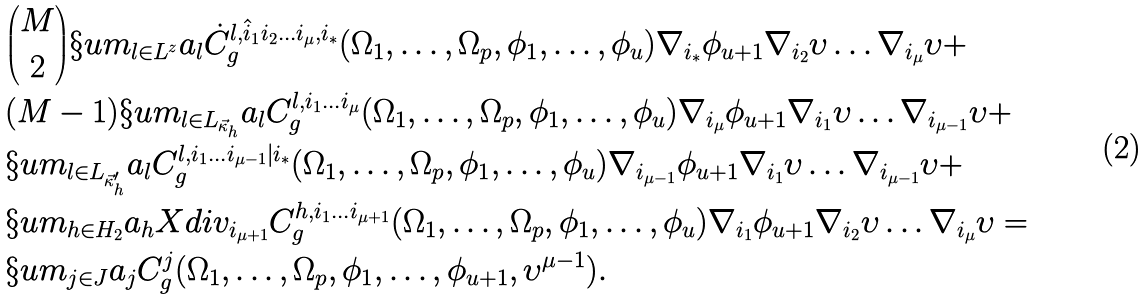Convert formula to latex. <formula><loc_0><loc_0><loc_500><loc_500>& { { M } \choose { 2 } } \S u m _ { l \in L ^ { z } } a _ { l } \dot { C } ^ { l , \hat { i } _ { 1 } i _ { 2 } \dots i _ { \mu } , i _ { * } } _ { g } ( \Omega _ { 1 } , \dots , \Omega _ { p } , \phi _ { 1 } , \dots , \phi _ { u } ) \nabla _ { i _ { * } } \phi _ { u + 1 } \nabla _ { i _ { 2 } } \upsilon \dots \nabla _ { i _ { \mu } } \upsilon + \\ & ( M - 1 ) \S u m _ { l \in L _ { \vec { \kappa } _ { h } } } a _ { l } C ^ { l , i _ { 1 } \dots i _ { \mu } } _ { g } ( \Omega _ { 1 } , \dots , \Omega _ { p } , \phi _ { 1 } , \dots , \phi _ { u } ) \nabla _ { i _ { \mu } } \phi _ { u + 1 } \nabla _ { i _ { 1 } } \upsilon \dots \nabla _ { i _ { \mu - 1 } } \upsilon + \\ & \S u m _ { l \in L _ { \vec { \kappa } ^ { \prime } _ { h } } } a _ { l } C ^ { l , i _ { 1 } \dots i _ { \mu - 1 } | i _ { * } } _ { g } ( \Omega _ { 1 } , \dots , \Omega _ { p } , \phi _ { 1 } , \dots , \phi _ { u } ) \nabla _ { i _ { \mu - 1 } } \phi _ { u + 1 } \nabla _ { i _ { 1 } } \upsilon \dots \nabla _ { i _ { \mu - 1 } } \upsilon + \\ & \S u m _ { h \in H _ { 2 } } a _ { h } X d i v _ { i _ { \mu + 1 } } C ^ { h , i _ { 1 } \dots i _ { \mu + 1 } } _ { g } ( \Omega _ { 1 } , \dots , \Omega _ { p } , \phi _ { 1 } , \dots , \phi _ { u } ) \nabla _ { i _ { 1 } } \phi _ { u + 1 } \nabla _ { i _ { 2 } } \upsilon \dots \nabla _ { i _ { \mu } } \upsilon = \\ & \S u m _ { j \in J } a _ { j } C ^ { j } _ { g } ( \Omega _ { 1 } , \dots , \Omega _ { p } , \phi _ { 1 } , \dots , \phi _ { u + 1 } , \upsilon ^ { \mu - 1 } ) .</formula> 